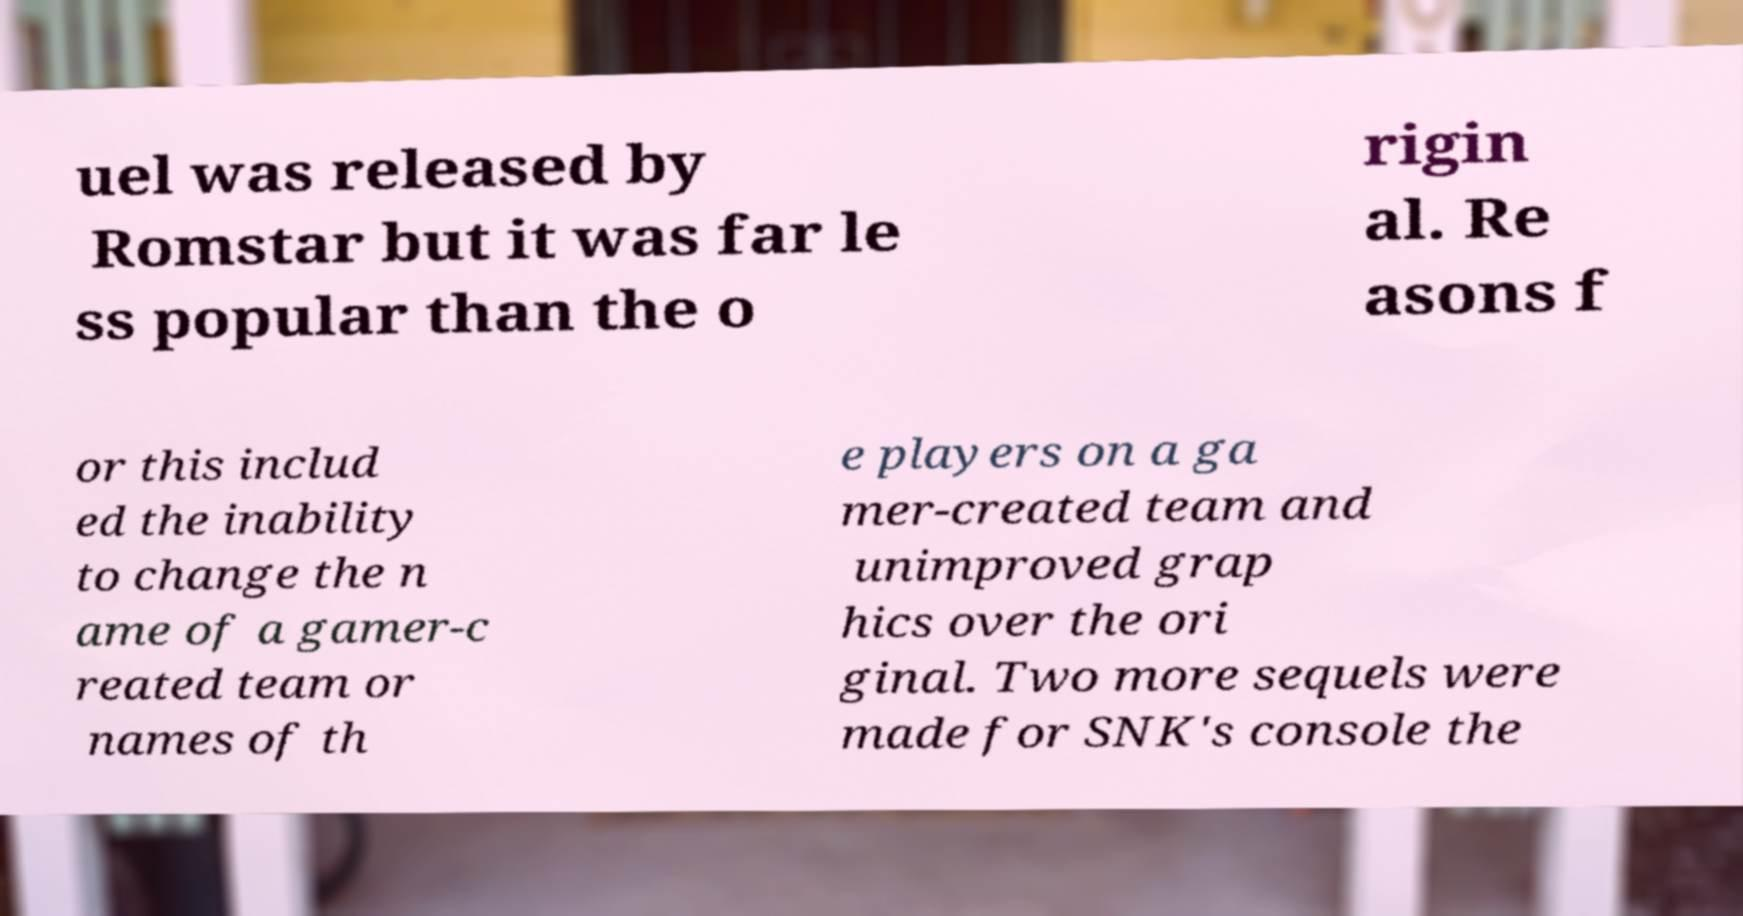Could you assist in decoding the text presented in this image and type it out clearly? uel was released by Romstar but it was far le ss popular than the o rigin al. Re asons f or this includ ed the inability to change the n ame of a gamer-c reated team or names of th e players on a ga mer-created team and unimproved grap hics over the ori ginal. Two more sequels were made for SNK's console the 